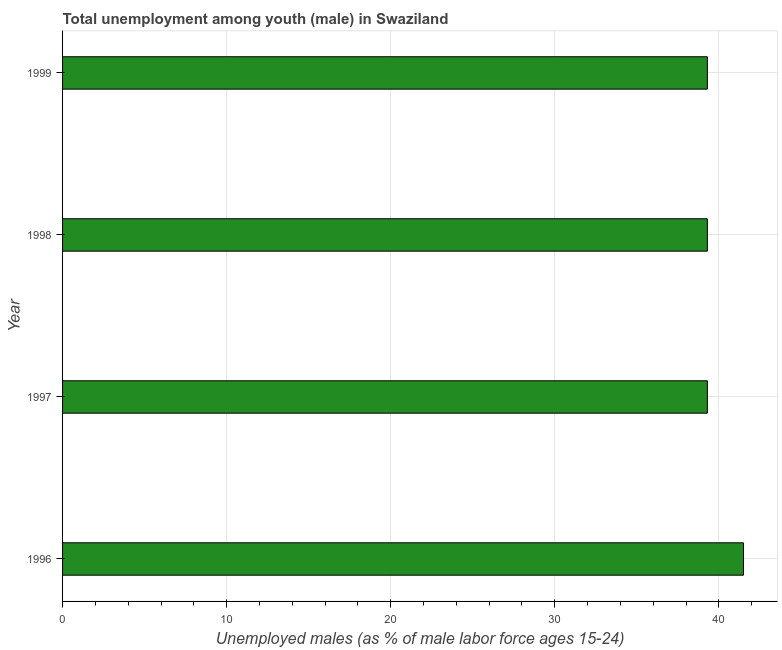What is the title of the graph?
Your answer should be very brief. Total unemployment among youth (male) in Swaziland. What is the label or title of the X-axis?
Make the answer very short. Unemployed males (as % of male labor force ages 15-24). What is the label or title of the Y-axis?
Provide a short and direct response. Year. What is the unemployed male youth population in 1997?
Provide a short and direct response. 39.3. Across all years, what is the maximum unemployed male youth population?
Make the answer very short. 41.5. Across all years, what is the minimum unemployed male youth population?
Provide a short and direct response. 39.3. In which year was the unemployed male youth population minimum?
Your answer should be compact. 1997. What is the sum of the unemployed male youth population?
Keep it short and to the point. 159.4. What is the average unemployed male youth population per year?
Your answer should be very brief. 39.85. What is the median unemployed male youth population?
Keep it short and to the point. 39.3. Do a majority of the years between 1997 and 1996 (inclusive) have unemployed male youth population greater than 32 %?
Your answer should be compact. No. Is the unemployed male youth population in 1996 less than that in 1999?
Ensure brevity in your answer.  No. Is the difference between the unemployed male youth population in 1997 and 1998 greater than the difference between any two years?
Provide a succinct answer. No. Is the sum of the unemployed male youth population in 1996 and 1997 greater than the maximum unemployed male youth population across all years?
Provide a succinct answer. Yes. How many years are there in the graph?
Make the answer very short. 4. What is the difference between two consecutive major ticks on the X-axis?
Provide a short and direct response. 10. What is the Unemployed males (as % of male labor force ages 15-24) of 1996?
Your answer should be very brief. 41.5. What is the Unemployed males (as % of male labor force ages 15-24) of 1997?
Provide a short and direct response. 39.3. What is the Unemployed males (as % of male labor force ages 15-24) of 1998?
Offer a terse response. 39.3. What is the Unemployed males (as % of male labor force ages 15-24) of 1999?
Make the answer very short. 39.3. What is the difference between the Unemployed males (as % of male labor force ages 15-24) in 1996 and 1997?
Your response must be concise. 2.2. What is the difference between the Unemployed males (as % of male labor force ages 15-24) in 1997 and 1998?
Give a very brief answer. 0. What is the difference between the Unemployed males (as % of male labor force ages 15-24) in 1998 and 1999?
Offer a terse response. 0. What is the ratio of the Unemployed males (as % of male labor force ages 15-24) in 1996 to that in 1997?
Your answer should be compact. 1.06. What is the ratio of the Unemployed males (as % of male labor force ages 15-24) in 1996 to that in 1998?
Your response must be concise. 1.06. What is the ratio of the Unemployed males (as % of male labor force ages 15-24) in 1996 to that in 1999?
Ensure brevity in your answer.  1.06. What is the ratio of the Unemployed males (as % of male labor force ages 15-24) in 1997 to that in 1998?
Your response must be concise. 1. What is the ratio of the Unemployed males (as % of male labor force ages 15-24) in 1997 to that in 1999?
Keep it short and to the point. 1. 